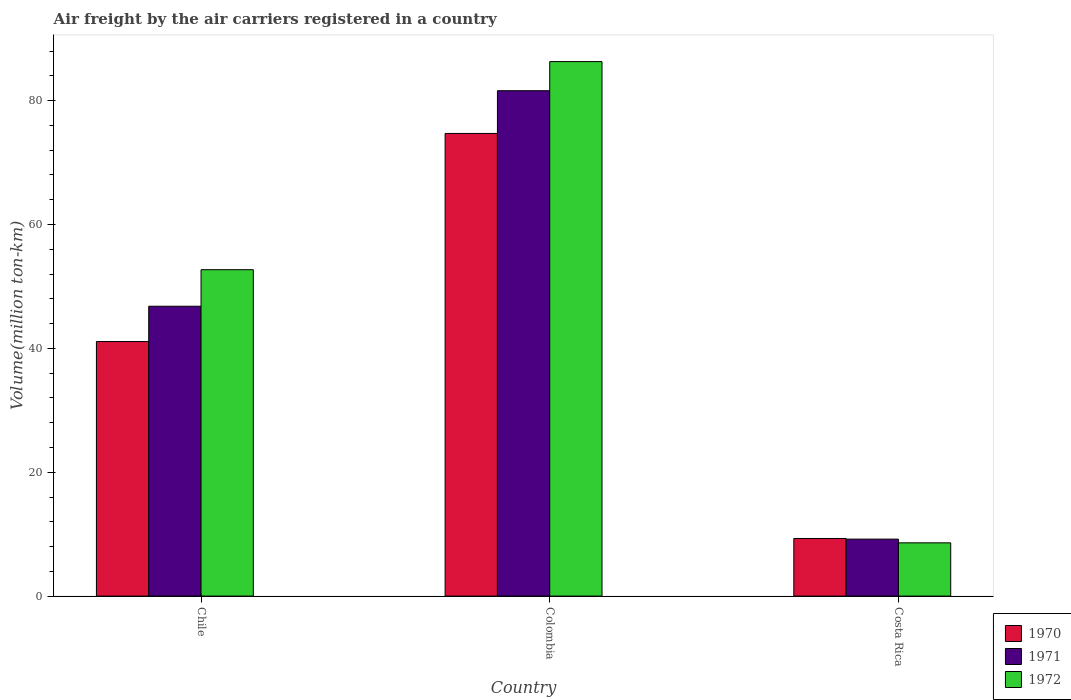How many different coloured bars are there?
Your answer should be very brief. 3. How many groups of bars are there?
Offer a very short reply. 3. How many bars are there on the 3rd tick from the left?
Provide a short and direct response. 3. How many bars are there on the 3rd tick from the right?
Your answer should be very brief. 3. What is the label of the 2nd group of bars from the left?
Make the answer very short. Colombia. What is the volume of the air carriers in 1970 in Chile?
Your response must be concise. 41.1. Across all countries, what is the maximum volume of the air carriers in 1972?
Provide a short and direct response. 86.3. Across all countries, what is the minimum volume of the air carriers in 1970?
Your response must be concise. 9.3. In which country was the volume of the air carriers in 1971 maximum?
Offer a terse response. Colombia. What is the total volume of the air carriers in 1970 in the graph?
Your response must be concise. 125.1. What is the difference between the volume of the air carriers in 1971 in Colombia and that in Costa Rica?
Offer a very short reply. 72.4. What is the difference between the volume of the air carriers in 1970 in Chile and the volume of the air carriers in 1972 in Costa Rica?
Provide a short and direct response. 32.5. What is the average volume of the air carriers in 1972 per country?
Ensure brevity in your answer.  49.2. What is the difference between the volume of the air carriers of/in 1972 and volume of the air carriers of/in 1971 in Costa Rica?
Offer a terse response. -0.6. What is the ratio of the volume of the air carriers in 1970 in Chile to that in Costa Rica?
Your answer should be very brief. 4.42. Is the volume of the air carriers in 1971 in Colombia less than that in Costa Rica?
Your answer should be compact. No. Is the difference between the volume of the air carriers in 1972 in Chile and Colombia greater than the difference between the volume of the air carriers in 1971 in Chile and Colombia?
Give a very brief answer. Yes. What is the difference between the highest and the second highest volume of the air carriers in 1972?
Give a very brief answer. -44.1. What is the difference between the highest and the lowest volume of the air carriers in 1970?
Offer a terse response. 65.4. What does the 1st bar from the right in Colombia represents?
Offer a terse response. 1972. Is it the case that in every country, the sum of the volume of the air carriers in 1970 and volume of the air carriers in 1972 is greater than the volume of the air carriers in 1971?
Give a very brief answer. Yes. How many bars are there?
Your answer should be compact. 9. What is the difference between two consecutive major ticks on the Y-axis?
Offer a very short reply. 20. How many legend labels are there?
Your answer should be compact. 3. How are the legend labels stacked?
Your response must be concise. Vertical. What is the title of the graph?
Make the answer very short. Air freight by the air carriers registered in a country. What is the label or title of the Y-axis?
Ensure brevity in your answer.  Volume(million ton-km). What is the Volume(million ton-km) of 1970 in Chile?
Your answer should be very brief. 41.1. What is the Volume(million ton-km) in 1971 in Chile?
Your answer should be compact. 46.8. What is the Volume(million ton-km) of 1972 in Chile?
Keep it short and to the point. 52.7. What is the Volume(million ton-km) of 1970 in Colombia?
Offer a very short reply. 74.7. What is the Volume(million ton-km) in 1971 in Colombia?
Give a very brief answer. 81.6. What is the Volume(million ton-km) in 1972 in Colombia?
Make the answer very short. 86.3. What is the Volume(million ton-km) in 1970 in Costa Rica?
Your response must be concise. 9.3. What is the Volume(million ton-km) in 1971 in Costa Rica?
Offer a very short reply. 9.2. What is the Volume(million ton-km) of 1972 in Costa Rica?
Your response must be concise. 8.6. Across all countries, what is the maximum Volume(million ton-km) of 1970?
Your answer should be compact. 74.7. Across all countries, what is the maximum Volume(million ton-km) in 1971?
Your answer should be compact. 81.6. Across all countries, what is the maximum Volume(million ton-km) of 1972?
Provide a succinct answer. 86.3. Across all countries, what is the minimum Volume(million ton-km) in 1970?
Provide a succinct answer. 9.3. Across all countries, what is the minimum Volume(million ton-km) of 1971?
Your answer should be compact. 9.2. Across all countries, what is the minimum Volume(million ton-km) in 1972?
Offer a very short reply. 8.6. What is the total Volume(million ton-km) of 1970 in the graph?
Your response must be concise. 125.1. What is the total Volume(million ton-km) of 1971 in the graph?
Provide a succinct answer. 137.6. What is the total Volume(million ton-km) in 1972 in the graph?
Provide a succinct answer. 147.6. What is the difference between the Volume(million ton-km) in 1970 in Chile and that in Colombia?
Provide a short and direct response. -33.6. What is the difference between the Volume(million ton-km) of 1971 in Chile and that in Colombia?
Your response must be concise. -34.8. What is the difference between the Volume(million ton-km) of 1972 in Chile and that in Colombia?
Your answer should be compact. -33.6. What is the difference between the Volume(million ton-km) of 1970 in Chile and that in Costa Rica?
Provide a succinct answer. 31.8. What is the difference between the Volume(million ton-km) in 1971 in Chile and that in Costa Rica?
Offer a very short reply. 37.6. What is the difference between the Volume(million ton-km) in 1972 in Chile and that in Costa Rica?
Ensure brevity in your answer.  44.1. What is the difference between the Volume(million ton-km) in 1970 in Colombia and that in Costa Rica?
Your answer should be very brief. 65.4. What is the difference between the Volume(million ton-km) in 1971 in Colombia and that in Costa Rica?
Your response must be concise. 72.4. What is the difference between the Volume(million ton-km) of 1972 in Colombia and that in Costa Rica?
Your answer should be compact. 77.7. What is the difference between the Volume(million ton-km) of 1970 in Chile and the Volume(million ton-km) of 1971 in Colombia?
Your answer should be compact. -40.5. What is the difference between the Volume(million ton-km) in 1970 in Chile and the Volume(million ton-km) in 1972 in Colombia?
Provide a succinct answer. -45.2. What is the difference between the Volume(million ton-km) of 1971 in Chile and the Volume(million ton-km) of 1972 in Colombia?
Your answer should be very brief. -39.5. What is the difference between the Volume(million ton-km) in 1970 in Chile and the Volume(million ton-km) in 1971 in Costa Rica?
Provide a short and direct response. 31.9. What is the difference between the Volume(million ton-km) in 1970 in Chile and the Volume(million ton-km) in 1972 in Costa Rica?
Provide a short and direct response. 32.5. What is the difference between the Volume(million ton-km) in 1971 in Chile and the Volume(million ton-km) in 1972 in Costa Rica?
Ensure brevity in your answer.  38.2. What is the difference between the Volume(million ton-km) in 1970 in Colombia and the Volume(million ton-km) in 1971 in Costa Rica?
Give a very brief answer. 65.5. What is the difference between the Volume(million ton-km) of 1970 in Colombia and the Volume(million ton-km) of 1972 in Costa Rica?
Your answer should be very brief. 66.1. What is the average Volume(million ton-km) in 1970 per country?
Give a very brief answer. 41.7. What is the average Volume(million ton-km) in 1971 per country?
Make the answer very short. 45.87. What is the average Volume(million ton-km) in 1972 per country?
Your answer should be very brief. 49.2. What is the difference between the Volume(million ton-km) in 1970 and Volume(million ton-km) in 1971 in Chile?
Give a very brief answer. -5.7. What is the difference between the Volume(million ton-km) in 1970 and Volume(million ton-km) in 1972 in Chile?
Give a very brief answer. -11.6. What is the difference between the Volume(million ton-km) in 1971 and Volume(million ton-km) in 1972 in Chile?
Provide a succinct answer. -5.9. What is the difference between the Volume(million ton-km) of 1970 and Volume(million ton-km) of 1972 in Costa Rica?
Provide a succinct answer. 0.7. What is the ratio of the Volume(million ton-km) of 1970 in Chile to that in Colombia?
Give a very brief answer. 0.55. What is the ratio of the Volume(million ton-km) of 1971 in Chile to that in Colombia?
Your response must be concise. 0.57. What is the ratio of the Volume(million ton-km) of 1972 in Chile to that in Colombia?
Your response must be concise. 0.61. What is the ratio of the Volume(million ton-km) in 1970 in Chile to that in Costa Rica?
Ensure brevity in your answer.  4.42. What is the ratio of the Volume(million ton-km) in 1971 in Chile to that in Costa Rica?
Offer a terse response. 5.09. What is the ratio of the Volume(million ton-km) in 1972 in Chile to that in Costa Rica?
Your answer should be compact. 6.13. What is the ratio of the Volume(million ton-km) of 1970 in Colombia to that in Costa Rica?
Provide a short and direct response. 8.03. What is the ratio of the Volume(million ton-km) of 1971 in Colombia to that in Costa Rica?
Offer a very short reply. 8.87. What is the ratio of the Volume(million ton-km) in 1972 in Colombia to that in Costa Rica?
Offer a terse response. 10.03. What is the difference between the highest and the second highest Volume(million ton-km) in 1970?
Provide a short and direct response. 33.6. What is the difference between the highest and the second highest Volume(million ton-km) of 1971?
Ensure brevity in your answer.  34.8. What is the difference between the highest and the second highest Volume(million ton-km) in 1972?
Offer a terse response. 33.6. What is the difference between the highest and the lowest Volume(million ton-km) of 1970?
Ensure brevity in your answer.  65.4. What is the difference between the highest and the lowest Volume(million ton-km) of 1971?
Provide a short and direct response. 72.4. What is the difference between the highest and the lowest Volume(million ton-km) in 1972?
Your response must be concise. 77.7. 